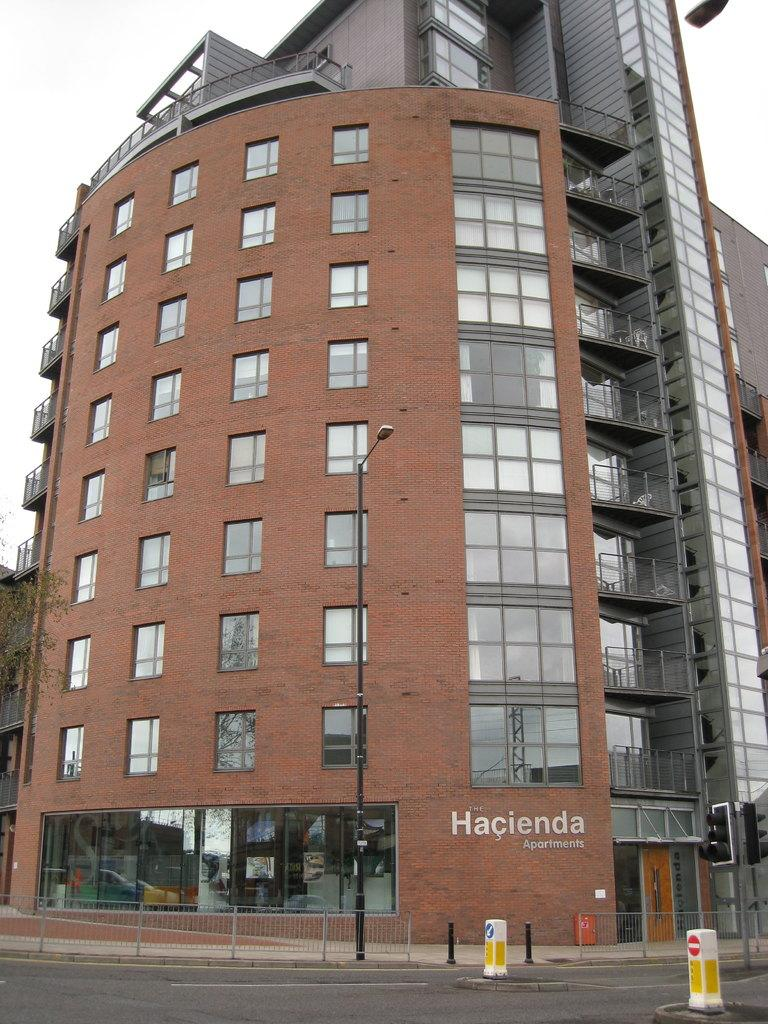<image>
Offer a succinct explanation of the picture presented. The apartment block shown is called The Hacienda apartments. 